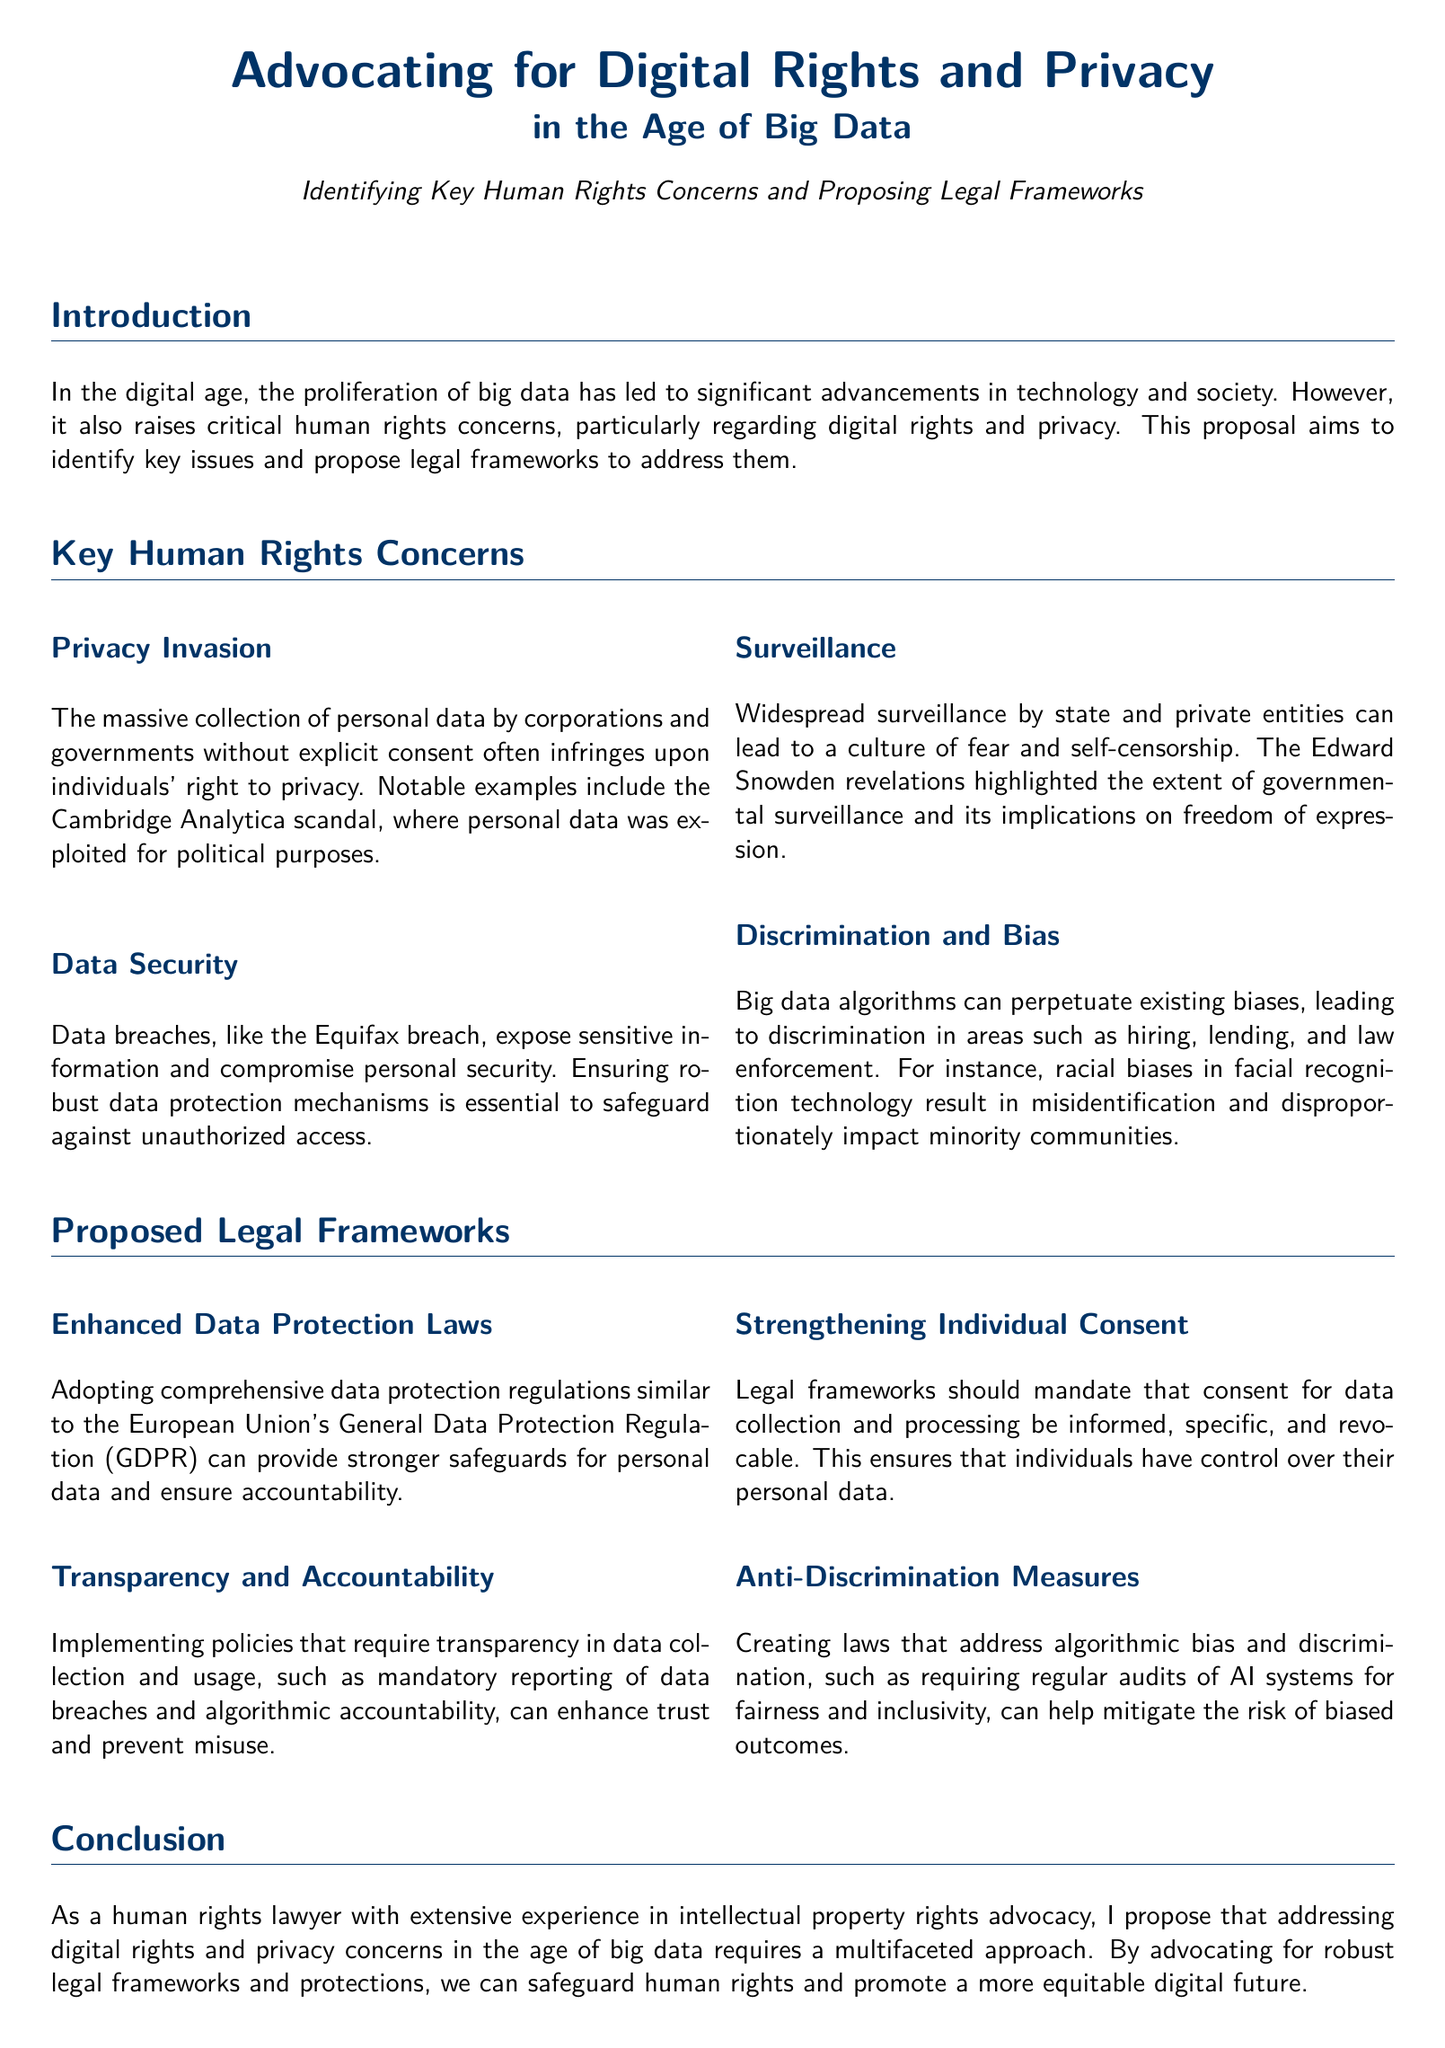What is the title of the proposal? The title of the proposal is prominently displayed at the beginning of the document and is "Advocating for Digital Rights and Privacy in the Age of Big Data."
Answer: Advocating for Digital Rights and Privacy in the Age of Big Data What is a notable example of privacy invasion mentioned? The document provides an example of the Cambridge Analytica scandal as a notable instance of privacy invasion.
Answer: Cambridge Analytica scandal Which data breach is referenced in the proposal? The proposal references the Equifax breach as an example of a significant data breach.
Answer: Equifax breach What legal framework is proposed for data protection? The document suggests adopting comprehensive data protection regulations similar to the European Union's GDPR.
Answer: GDPR Which human rights issue is tied to surveillance according to the document? The document states that widespread surveillance can lead to a culture of fear and self-censorship.
Answer: Culture of fear and self-censorship What is one suggested measure for addressing algorithmic bias? The proposal suggests requiring regular audits of AI systems for fairness and inclusivity as a measure to combat algorithmic bias.
Answer: Regular audits of AI systems What type of consent should be mandated according to the proposal? The document specifies that consent for data collection should be informed, specific, and revocable.
Answer: Informed, specific, and revocable Who are the authors cited in the references? The proposal includes authors such as Cohen, Weaver, Greenwald, and Buolamwini & Gebru in the references section.
Answer: Cohen, Weaver, Greenwald, Buolamwini & Gebru What is the main conclusion of the proposal? The main conclusion emphasizes the need for robust legal frameworks and protections to safeguard human rights in the digital age.
Answer: Robust legal frameworks and protections 